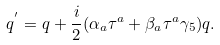<formula> <loc_0><loc_0><loc_500><loc_500>q ^ { ^ { \prime } } & = q + \frac { i } { 2 } ( \alpha _ { a } \tau ^ { a } + \beta _ { a } \tau ^ { a } \gamma _ { 5 } ) q .</formula> 